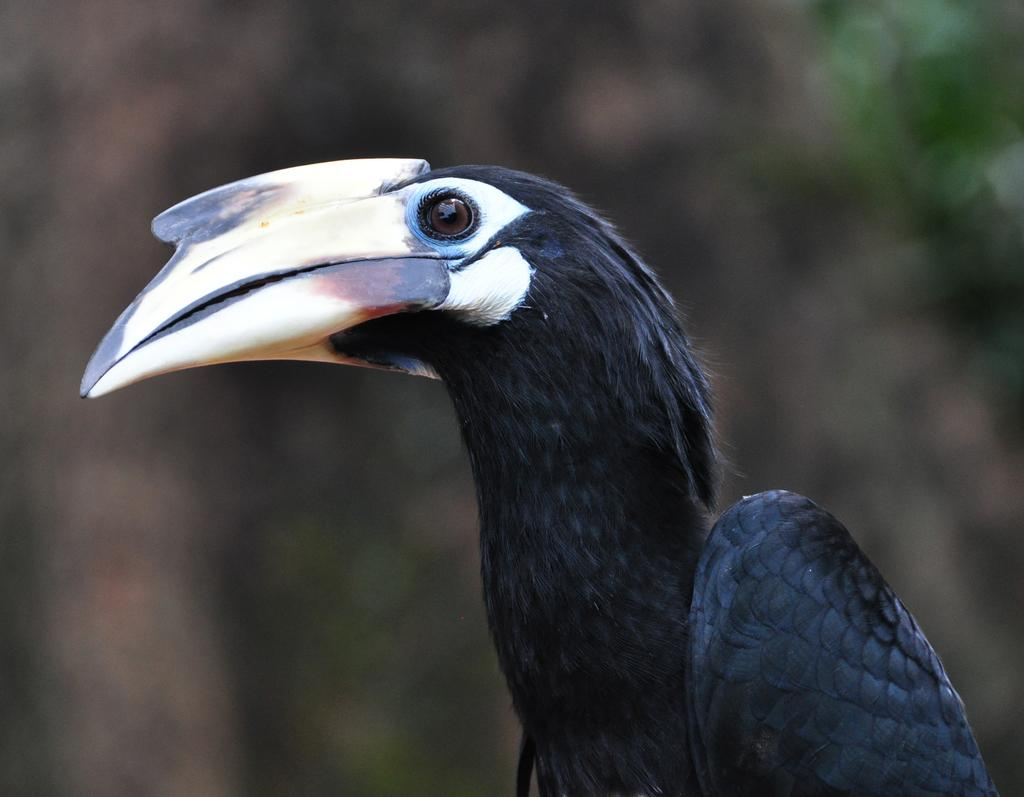What type of animal is in the image? There is a bird in the image. What is a distinctive feature of the bird? The bird has a long beak. What color is the bird? The bird is black in color. What can be seen in the background of the image? There are plants in the background of the image, but they are not clearly visible. What brand of toothpaste is the bird using in the image? There is no toothpaste present in the image, and the bird is not using any. How many pets are visible in the image? There are no pets visible in the image; only the bird is present. 